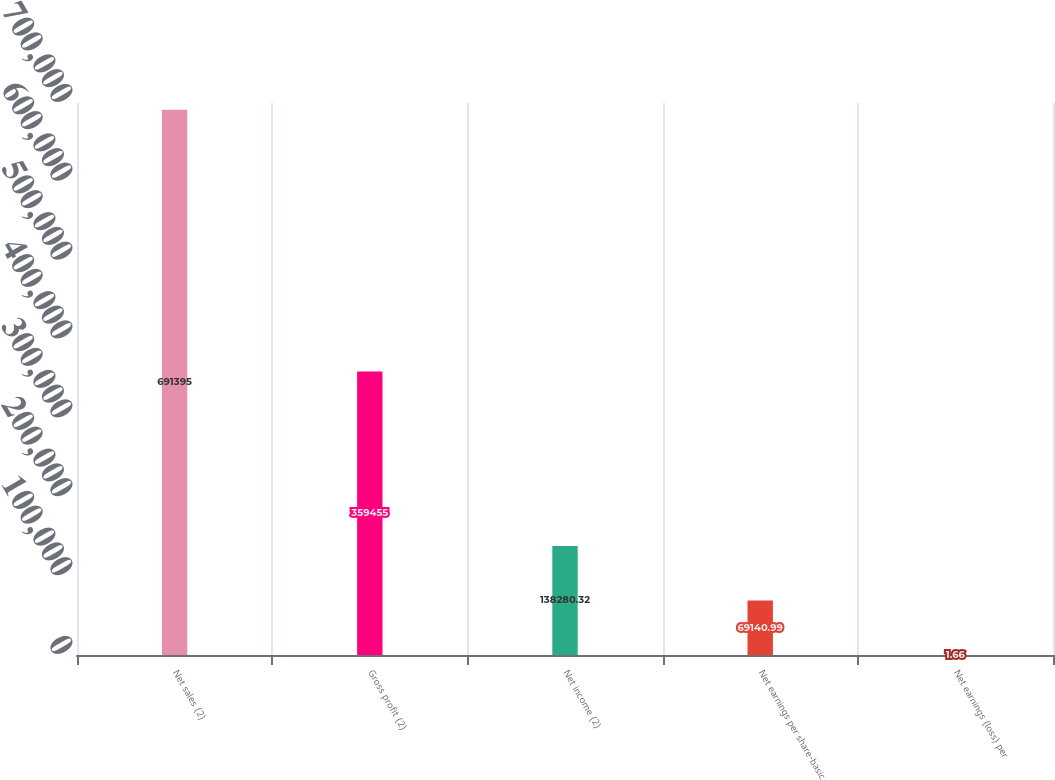Convert chart to OTSL. <chart><loc_0><loc_0><loc_500><loc_500><bar_chart><fcel>Net sales (2)<fcel>Gross profit (2)<fcel>Net income (2)<fcel>Net earnings per share-basic<fcel>Net earnings (loss) per<nl><fcel>691395<fcel>359455<fcel>138280<fcel>69141<fcel>1.66<nl></chart> 